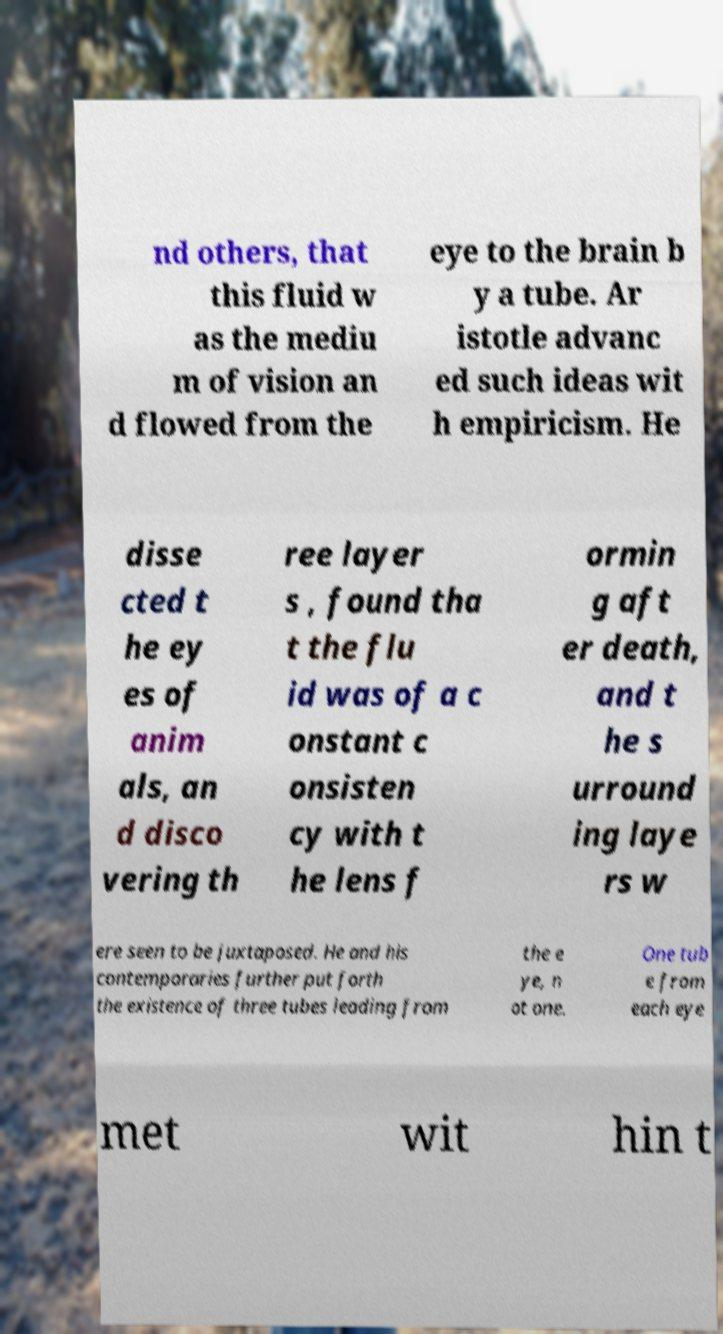Could you assist in decoding the text presented in this image and type it out clearly? nd others, that this fluid w as the mediu m of vision an d flowed from the eye to the brain b y a tube. Ar istotle advanc ed such ideas wit h empiricism. He disse cted t he ey es of anim als, an d disco vering th ree layer s , found tha t the flu id was of a c onstant c onsisten cy with t he lens f ormin g aft er death, and t he s urround ing laye rs w ere seen to be juxtaposed. He and his contemporaries further put forth the existence of three tubes leading from the e ye, n ot one. One tub e from each eye met wit hin t 